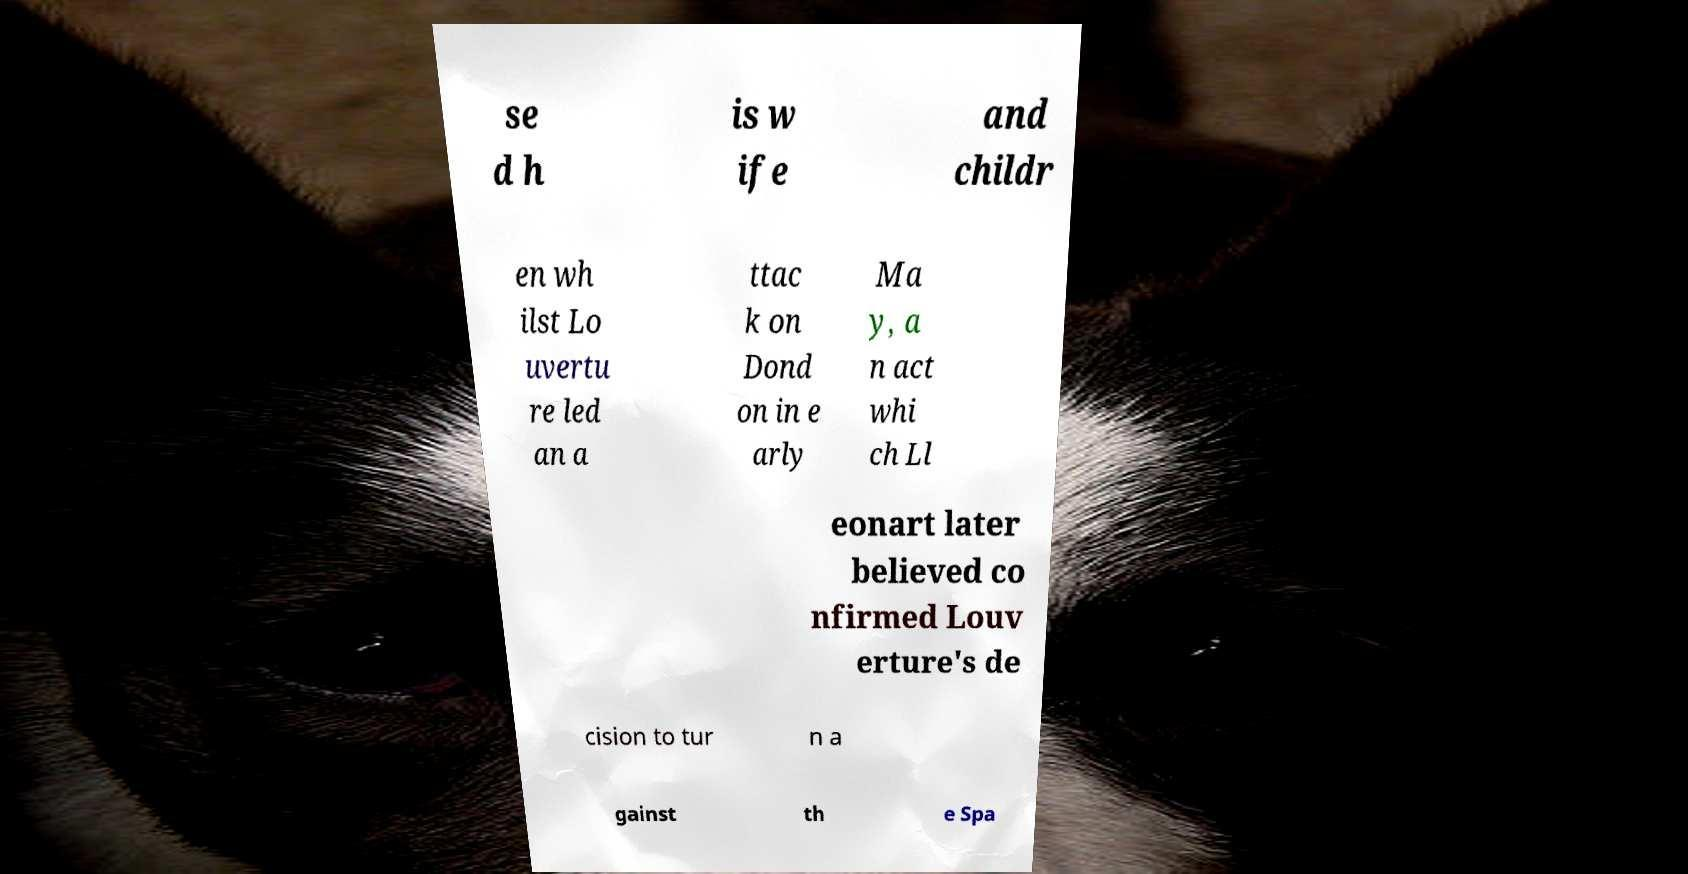Can you accurately transcribe the text from the provided image for me? se d h is w ife and childr en wh ilst Lo uvertu re led an a ttac k on Dond on in e arly Ma y, a n act whi ch Ll eonart later believed co nfirmed Louv erture's de cision to tur n a gainst th e Spa 